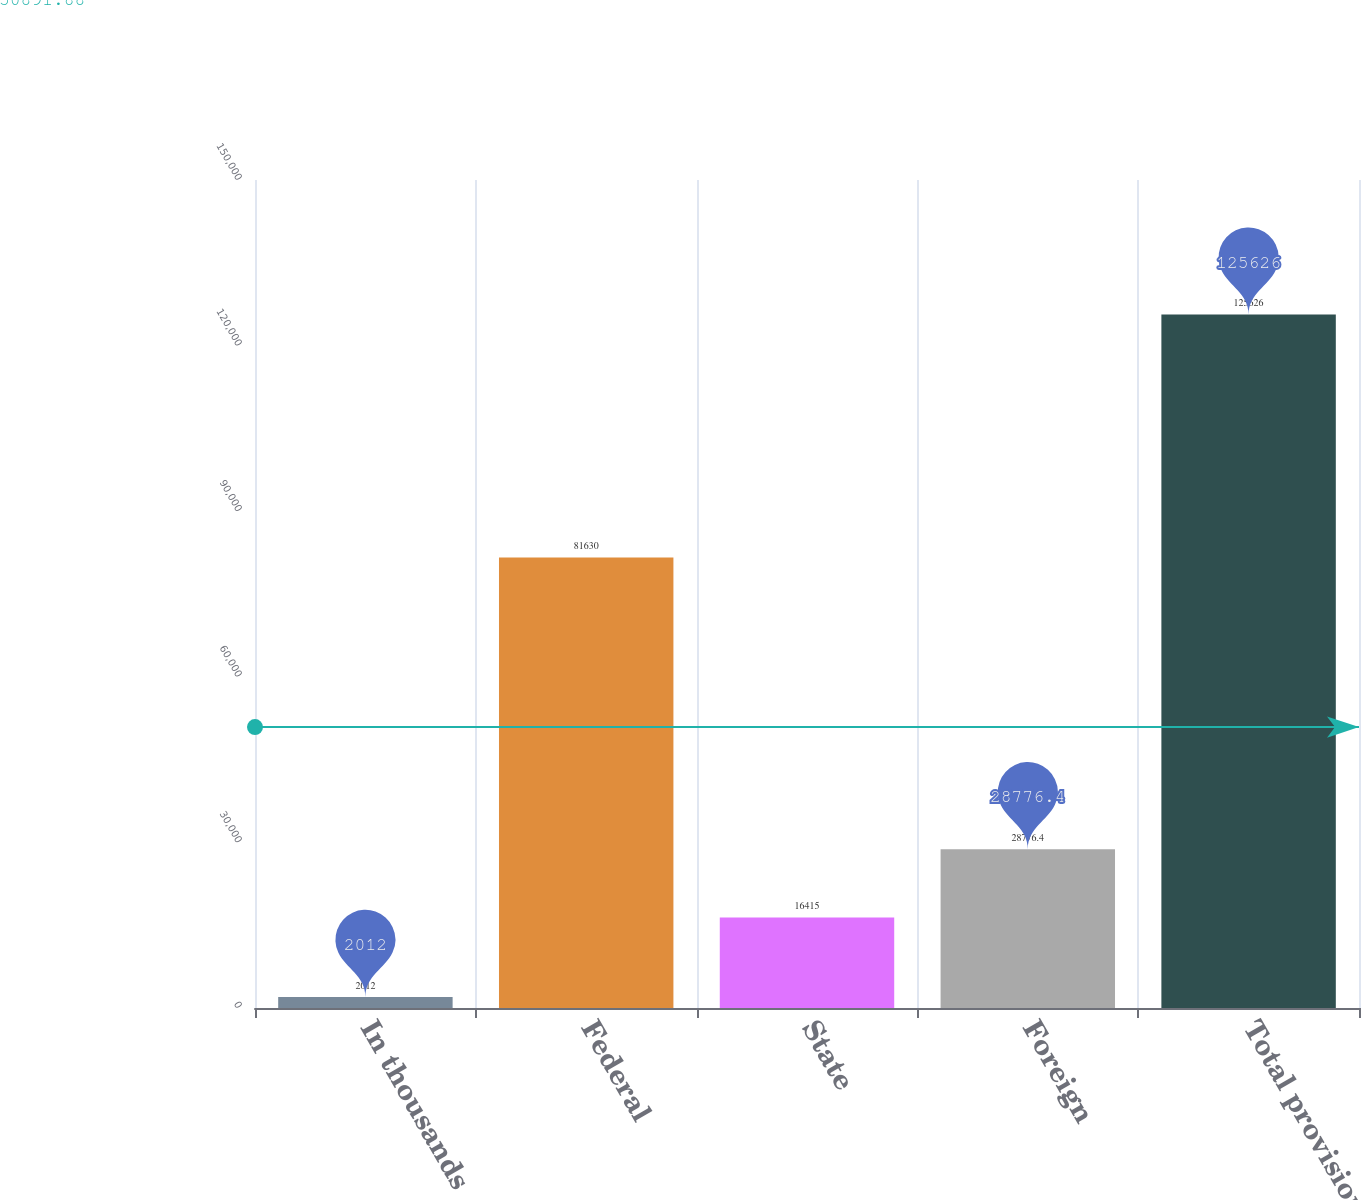Convert chart. <chart><loc_0><loc_0><loc_500><loc_500><bar_chart><fcel>In thousands<fcel>Federal<fcel>State<fcel>Foreign<fcel>Total provision<nl><fcel>2012<fcel>81630<fcel>16415<fcel>28776.4<fcel>125626<nl></chart> 